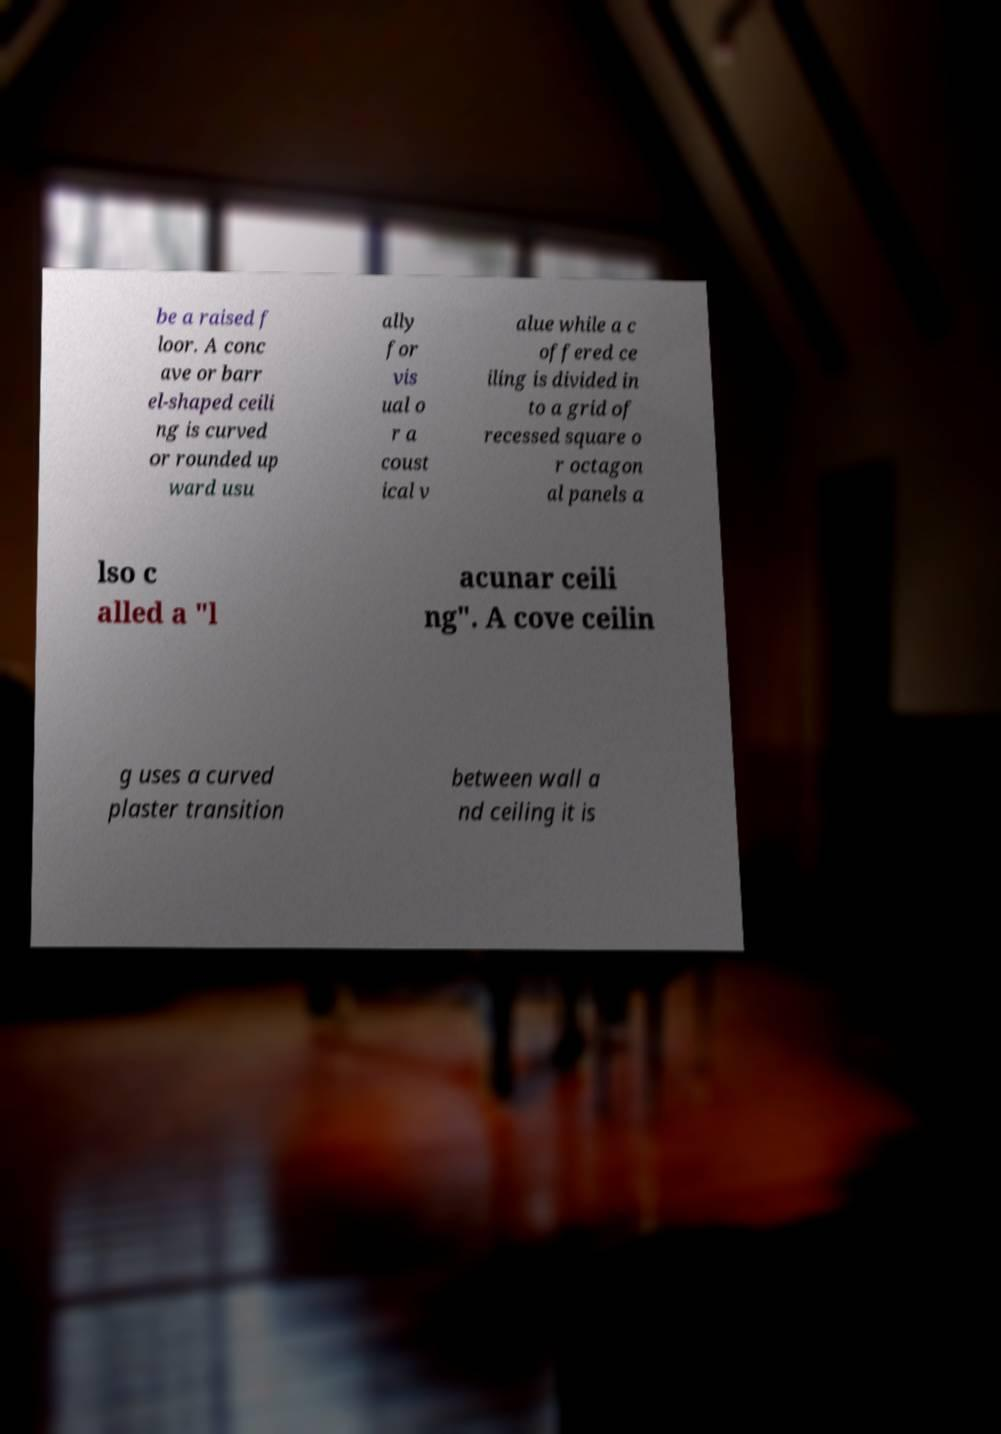What messages or text are displayed in this image? I need them in a readable, typed format. be a raised f loor. A conc ave or barr el-shaped ceili ng is curved or rounded up ward usu ally for vis ual o r a coust ical v alue while a c offered ce iling is divided in to a grid of recessed square o r octagon al panels a lso c alled a "l acunar ceili ng". A cove ceilin g uses a curved plaster transition between wall a nd ceiling it is 